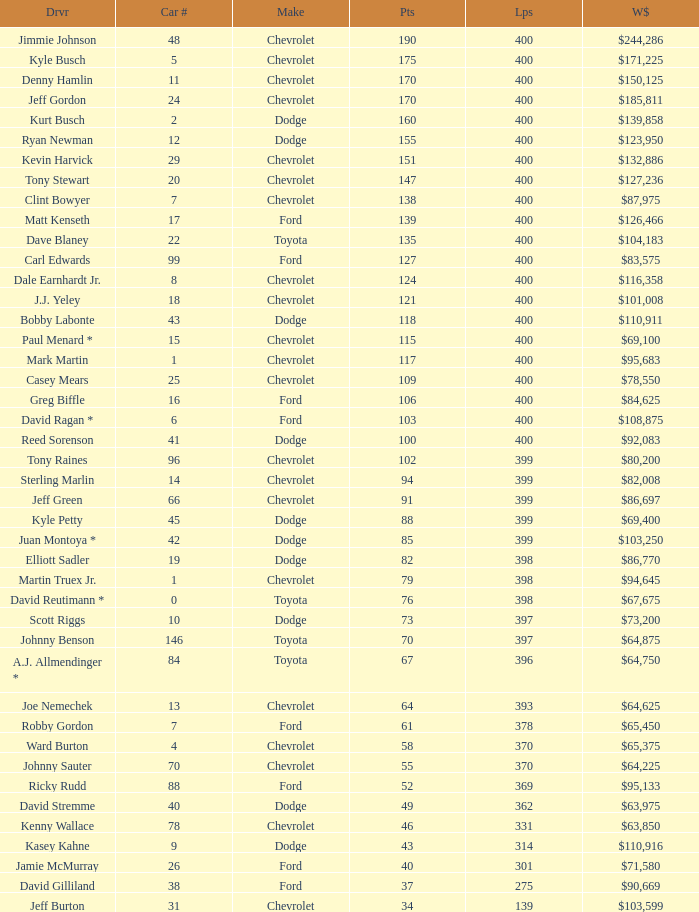What were the winnings for the Chevrolet with a number larger than 29 and scored 102 points? $80,200. Can you parse all the data within this table? {'header': ['Drvr', 'Car #', 'Make', 'Pts', 'Lps', 'W$'], 'rows': [['Jimmie Johnson', '48', 'Chevrolet', '190', '400', '$244,286'], ['Kyle Busch', '5', 'Chevrolet', '175', '400', '$171,225'], ['Denny Hamlin', '11', 'Chevrolet', '170', '400', '$150,125'], ['Jeff Gordon', '24', 'Chevrolet', '170', '400', '$185,811'], ['Kurt Busch', '2', 'Dodge', '160', '400', '$139,858'], ['Ryan Newman', '12', 'Dodge', '155', '400', '$123,950'], ['Kevin Harvick', '29', 'Chevrolet', '151', '400', '$132,886'], ['Tony Stewart', '20', 'Chevrolet', '147', '400', '$127,236'], ['Clint Bowyer', '7', 'Chevrolet', '138', '400', '$87,975'], ['Matt Kenseth', '17', 'Ford', '139', '400', '$126,466'], ['Dave Blaney', '22', 'Toyota', '135', '400', '$104,183'], ['Carl Edwards', '99', 'Ford', '127', '400', '$83,575'], ['Dale Earnhardt Jr.', '8', 'Chevrolet', '124', '400', '$116,358'], ['J.J. Yeley', '18', 'Chevrolet', '121', '400', '$101,008'], ['Bobby Labonte', '43', 'Dodge', '118', '400', '$110,911'], ['Paul Menard *', '15', 'Chevrolet', '115', '400', '$69,100'], ['Mark Martin', '1', 'Chevrolet', '117', '400', '$95,683'], ['Casey Mears', '25', 'Chevrolet', '109', '400', '$78,550'], ['Greg Biffle', '16', 'Ford', '106', '400', '$84,625'], ['David Ragan *', '6', 'Ford', '103', '400', '$108,875'], ['Reed Sorenson', '41', 'Dodge', '100', '400', '$92,083'], ['Tony Raines', '96', 'Chevrolet', '102', '399', '$80,200'], ['Sterling Marlin', '14', 'Chevrolet', '94', '399', '$82,008'], ['Jeff Green', '66', 'Chevrolet', '91', '399', '$86,697'], ['Kyle Petty', '45', 'Dodge', '88', '399', '$69,400'], ['Juan Montoya *', '42', 'Dodge', '85', '399', '$103,250'], ['Elliott Sadler', '19', 'Dodge', '82', '398', '$86,770'], ['Martin Truex Jr.', '1', 'Chevrolet', '79', '398', '$94,645'], ['David Reutimann *', '0', 'Toyota', '76', '398', '$67,675'], ['Scott Riggs', '10', 'Dodge', '73', '397', '$73,200'], ['Johnny Benson', '146', 'Toyota', '70', '397', '$64,875'], ['A.J. Allmendinger *', '84', 'Toyota', '67', '396', '$64,750'], ['Joe Nemechek', '13', 'Chevrolet', '64', '393', '$64,625'], ['Robby Gordon', '7', 'Ford', '61', '378', '$65,450'], ['Ward Burton', '4', 'Chevrolet', '58', '370', '$65,375'], ['Johnny Sauter', '70', 'Chevrolet', '55', '370', '$64,225'], ['Ricky Rudd', '88', 'Ford', '52', '369', '$95,133'], ['David Stremme', '40', 'Dodge', '49', '362', '$63,975'], ['Kenny Wallace', '78', 'Chevrolet', '46', '331', '$63,850'], ['Kasey Kahne', '9', 'Dodge', '43', '314', '$110,916'], ['Jamie McMurray', '26', 'Ford', '40', '301', '$71,580'], ['David Gilliland', '38', 'Ford', '37', '275', '$90,669'], ['Jeff Burton', '31', 'Chevrolet', '34', '139', '$103,599']]} 